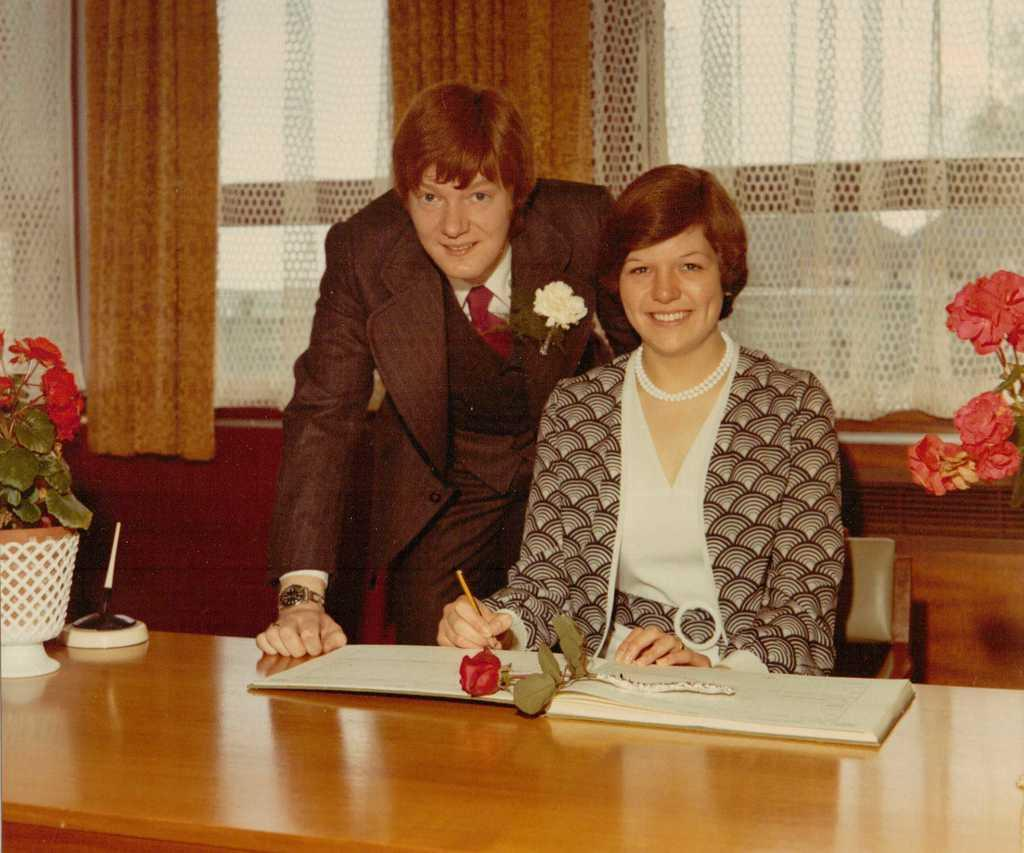What is the woman in the image doing? The woman is sitting in a chair and writing in a book. Who is present in the image besides the woman? There is a man standing behind the woman. How is the man positioned in relation to the woman? The man is bent a little. What can be seen on the table in the image? There are two flower vases on the table. What is on the book that the woman is writing in? There is a flower on the book. Can you tell me how many basketballs are visible in the image? There are no basketballs present in the image. What fact about the book is mentioned in the image? The image does not mention any specific facts about the book; it only shows a flower on the book. 